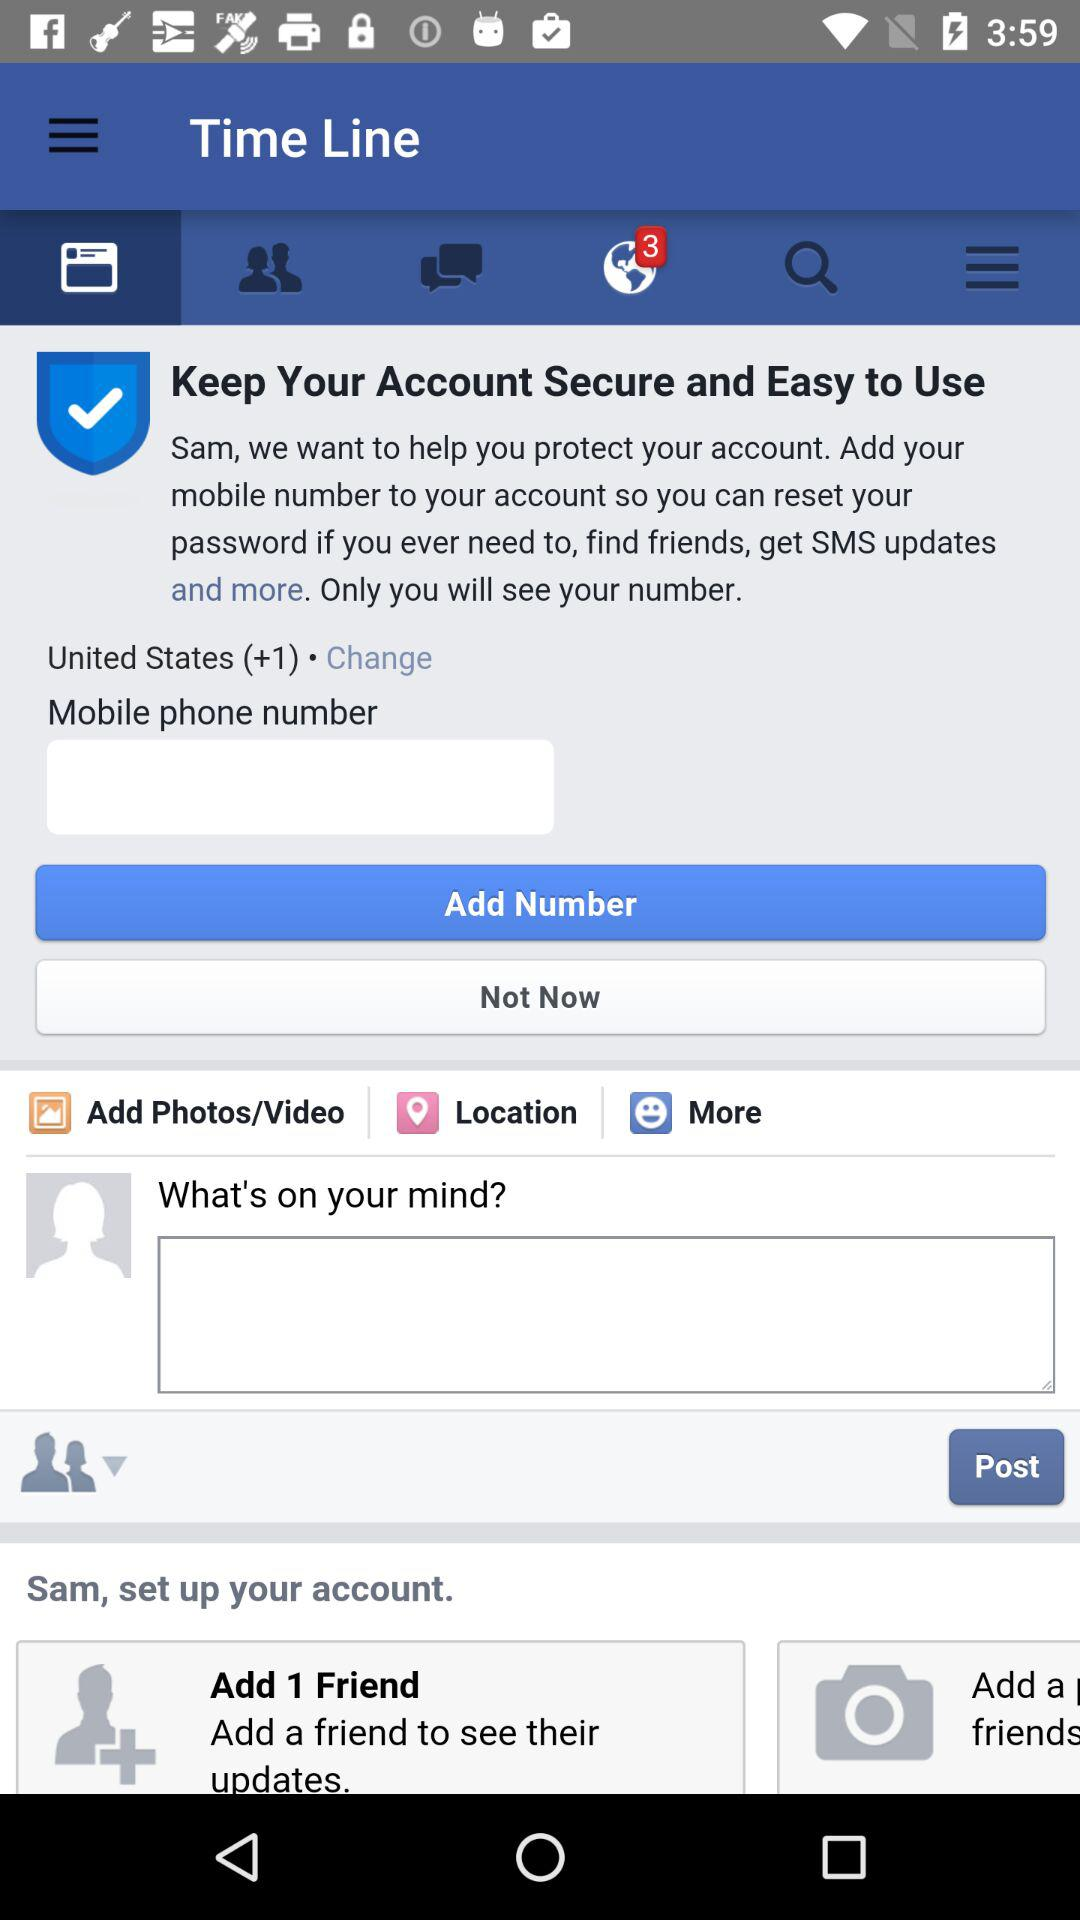How many unread notifications are there? There are 3 unread notifications. 